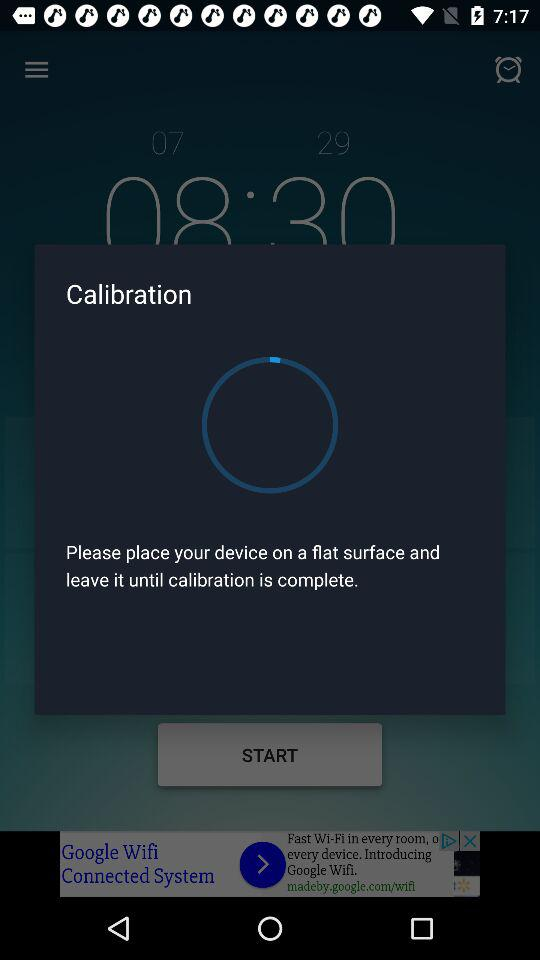What am I able to gain from this experience?
When the provided information is insufficient, respond with <no answer>. <no answer> 